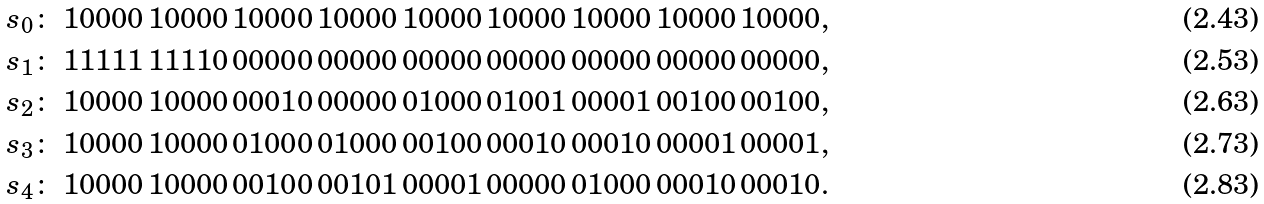<formula> <loc_0><loc_0><loc_500><loc_500>s _ { 0 } \colon \ 1 0 0 0 0 \, 1 0 0 0 0 \, 1 0 0 0 0 \, 1 0 0 0 0 \, 1 0 0 0 0 \, 1 0 0 0 0 \, 1 0 0 0 0 \, 1 0 0 0 0 \, 1 0 0 0 0 , \\ s _ { 1 } \colon \ 1 1 1 1 1 \, 1 1 1 1 0 \, 0 0 0 0 0 \, 0 0 0 0 0 \, 0 0 0 0 0 \, 0 0 0 0 0 \, 0 0 0 0 0 \, 0 0 0 0 0 \, 0 0 0 0 0 , \\ s _ { 2 } \colon \ 1 0 0 0 0 \, 1 0 0 0 0 \, 0 0 0 1 0 \, 0 0 0 0 0 \, 0 1 0 0 0 \, 0 1 0 0 1 \, 0 0 0 0 1 \, 0 0 1 0 0 \, 0 0 1 0 0 , \\ s _ { 3 } \colon \ 1 0 0 0 0 \, 1 0 0 0 0 \, 0 1 0 0 0 \, 0 1 0 0 0 \, 0 0 1 0 0 \, 0 0 0 1 0 \, 0 0 0 1 0 \, 0 0 0 0 1 \, 0 0 0 0 1 , \\ s _ { 4 } \colon \ 1 0 0 0 0 \, 1 0 0 0 0 \, 0 0 1 0 0 \, 0 0 1 0 1 \, 0 0 0 0 1 \, 0 0 0 0 0 \, 0 1 0 0 0 \, 0 0 0 1 0 \, 0 0 0 1 0 .</formula> 